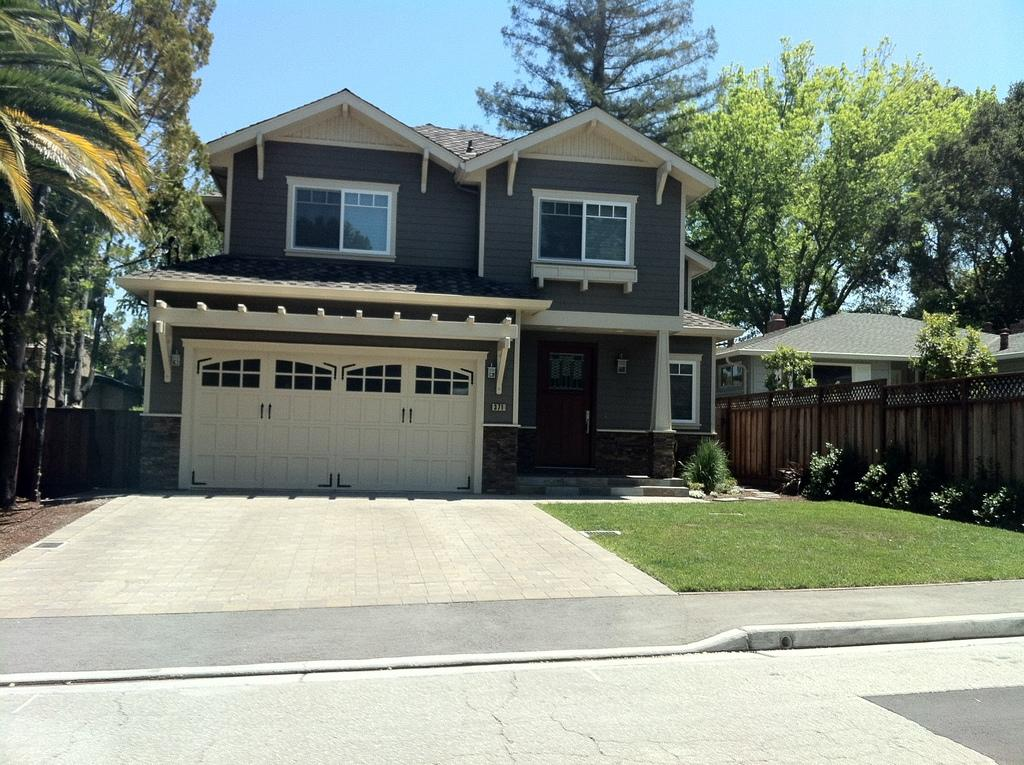What type of structures can be seen in the image? There are buildings in the image. What type of vegetation is present in the image? There are trees and shrubs in the image. What architectural features can be seen in the image? There are walls, doors, and windows in the image. What part of the natural environment is visible in the image? The ground and the sky are visible in the image. Can you see any attempts to stick a rainbow to the wall in the image? There is no mention of a rainbow or any attempt to stick it to the wall in the image. 